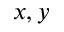Convert formula to latex. <formula><loc_0><loc_0><loc_500><loc_500>x , y</formula> 